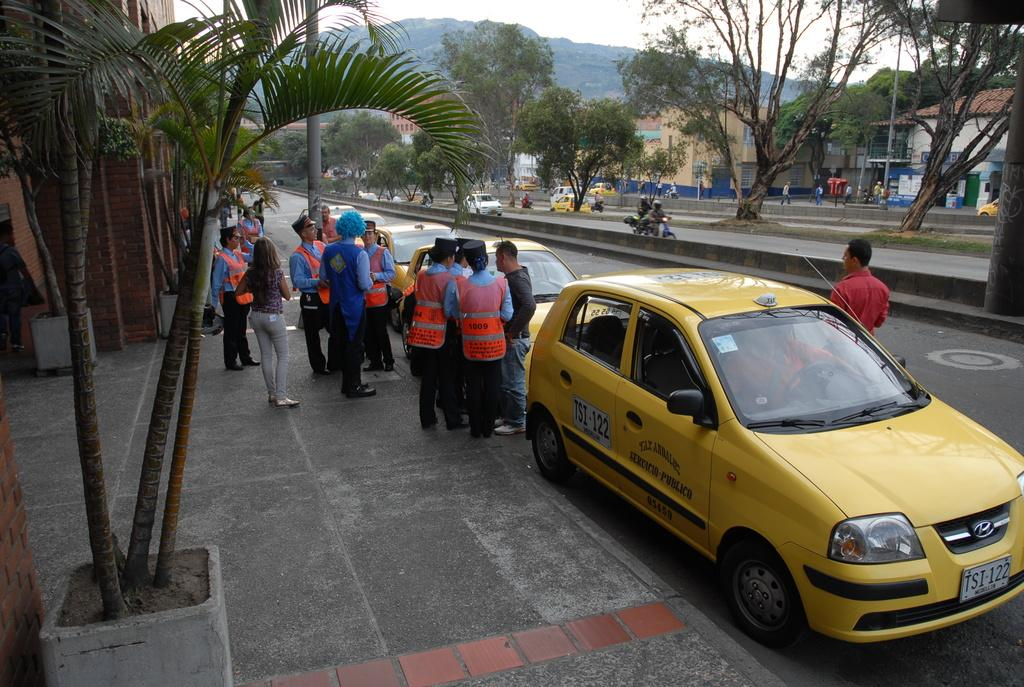<image>
Give a short and clear explanation of the subsequent image. A yellow taxi has a license on the door that says TSI-122. 